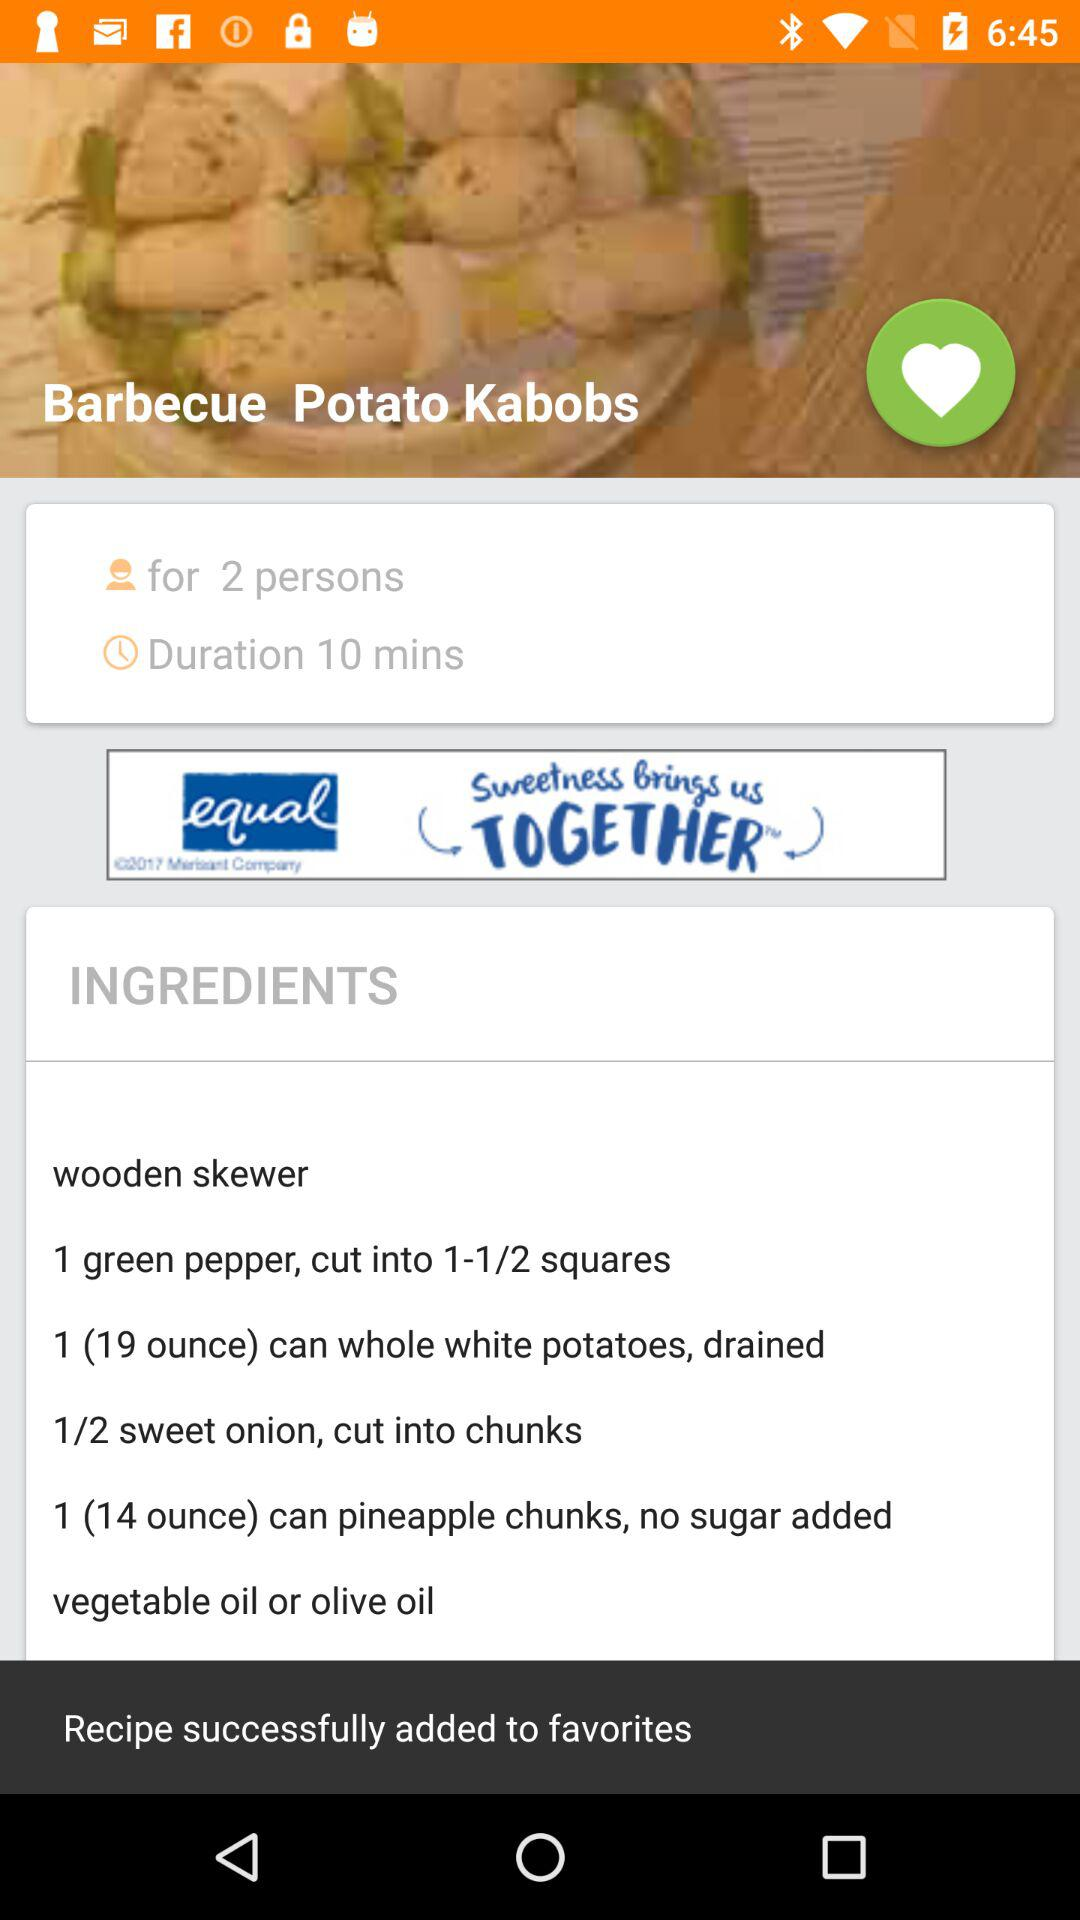For how many people is the dish made? The dish is made for 2 people. 